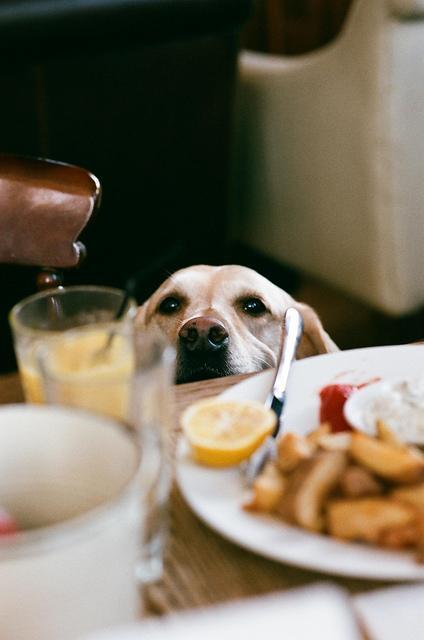How many cups are on the table?
Give a very brief answer. 2. How many cups are there?
Give a very brief answer. 2. How many chairs are visible?
Give a very brief answer. 2. How many people are shown?
Give a very brief answer. 0. 